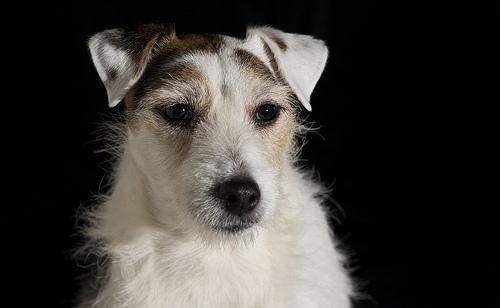How many animals are in this picture?
Give a very brief answer. 1. How many ears are in this picture?
Give a very brief answer. 2. 